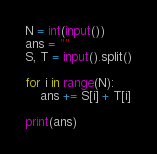<code> <loc_0><loc_0><loc_500><loc_500><_Python_>N = int(input())
ans = ""
S, T = input().split()

for i in range(N):
    ans += S[i] + T[i]

print(ans)</code> 